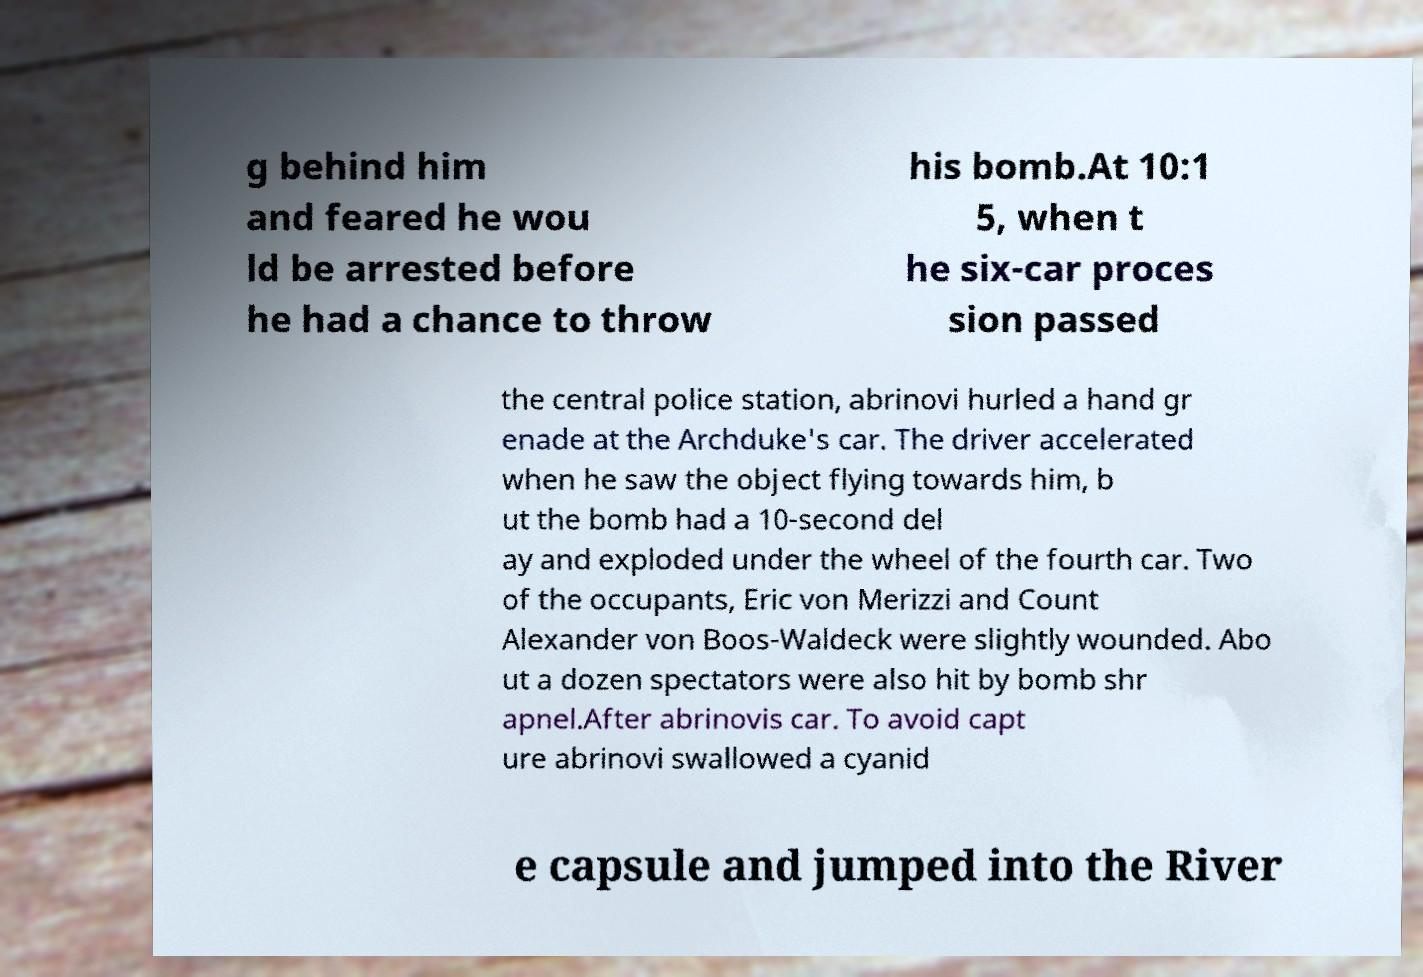What messages or text are displayed in this image? I need them in a readable, typed format. g behind him and feared he wou ld be arrested before he had a chance to throw his bomb.At 10:1 5, when t he six-car proces sion passed the central police station, abrinovi hurled a hand gr enade at the Archduke's car. The driver accelerated when he saw the object flying towards him, b ut the bomb had a 10-second del ay and exploded under the wheel of the fourth car. Two of the occupants, Eric von Merizzi and Count Alexander von Boos-Waldeck were slightly wounded. Abo ut a dozen spectators were also hit by bomb shr apnel.After abrinovis car. To avoid capt ure abrinovi swallowed a cyanid e capsule and jumped into the River 